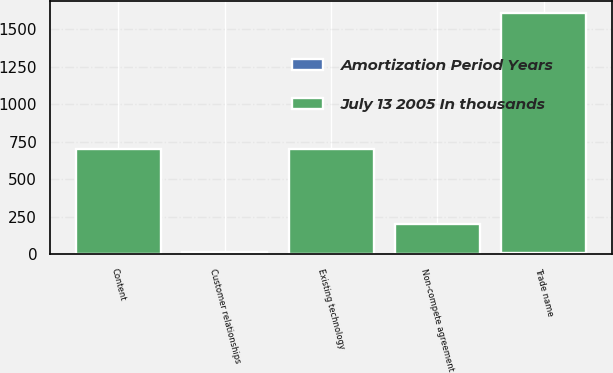<chart> <loc_0><loc_0><loc_500><loc_500><stacked_bar_chart><ecel><fcel>Content<fcel>Customer relationships<fcel>Non-compete agreement<fcel>Existing technology<fcel>Trade name<nl><fcel>July 13 2005 In thousands<fcel>700<fcel>7<fcel>200<fcel>700<fcel>1600<nl><fcel>Amortization Period Years<fcel>2<fcel>7<fcel>2<fcel>2<fcel>7<nl></chart> 